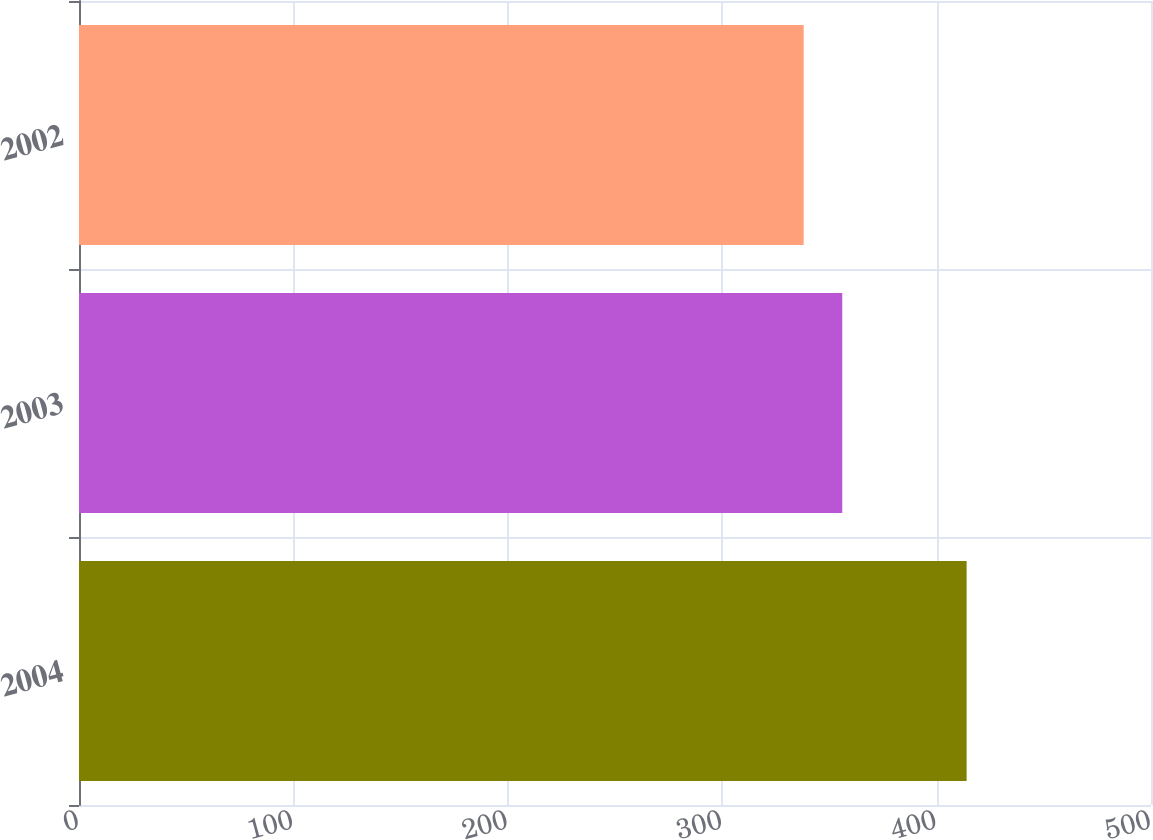Convert chart to OTSL. <chart><loc_0><loc_0><loc_500><loc_500><bar_chart><fcel>2004<fcel>2003<fcel>2002<nl><fcel>414<fcel>356<fcel>338<nl></chart> 